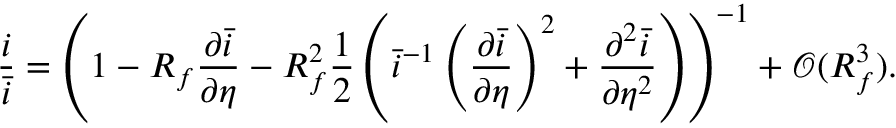Convert formula to latex. <formula><loc_0><loc_0><loc_500><loc_500>\frac { i } { \bar { i } } = \left ( 1 - R _ { f } \frac { \partial \bar { i } } { \partial \eta } - R _ { f } ^ { 2 } \frac { 1 } { 2 } \left ( \bar { i } ^ { - 1 } \left ( \frac { \partial \bar { i } } { \partial \eta } \right ) ^ { 2 } + \frac { \partial ^ { 2 } \bar { i } } { \partial \eta ^ { 2 } } \right ) \right ) ^ { - 1 } + \mathcal { O } ( R _ { f } ^ { 3 } ) .</formula> 